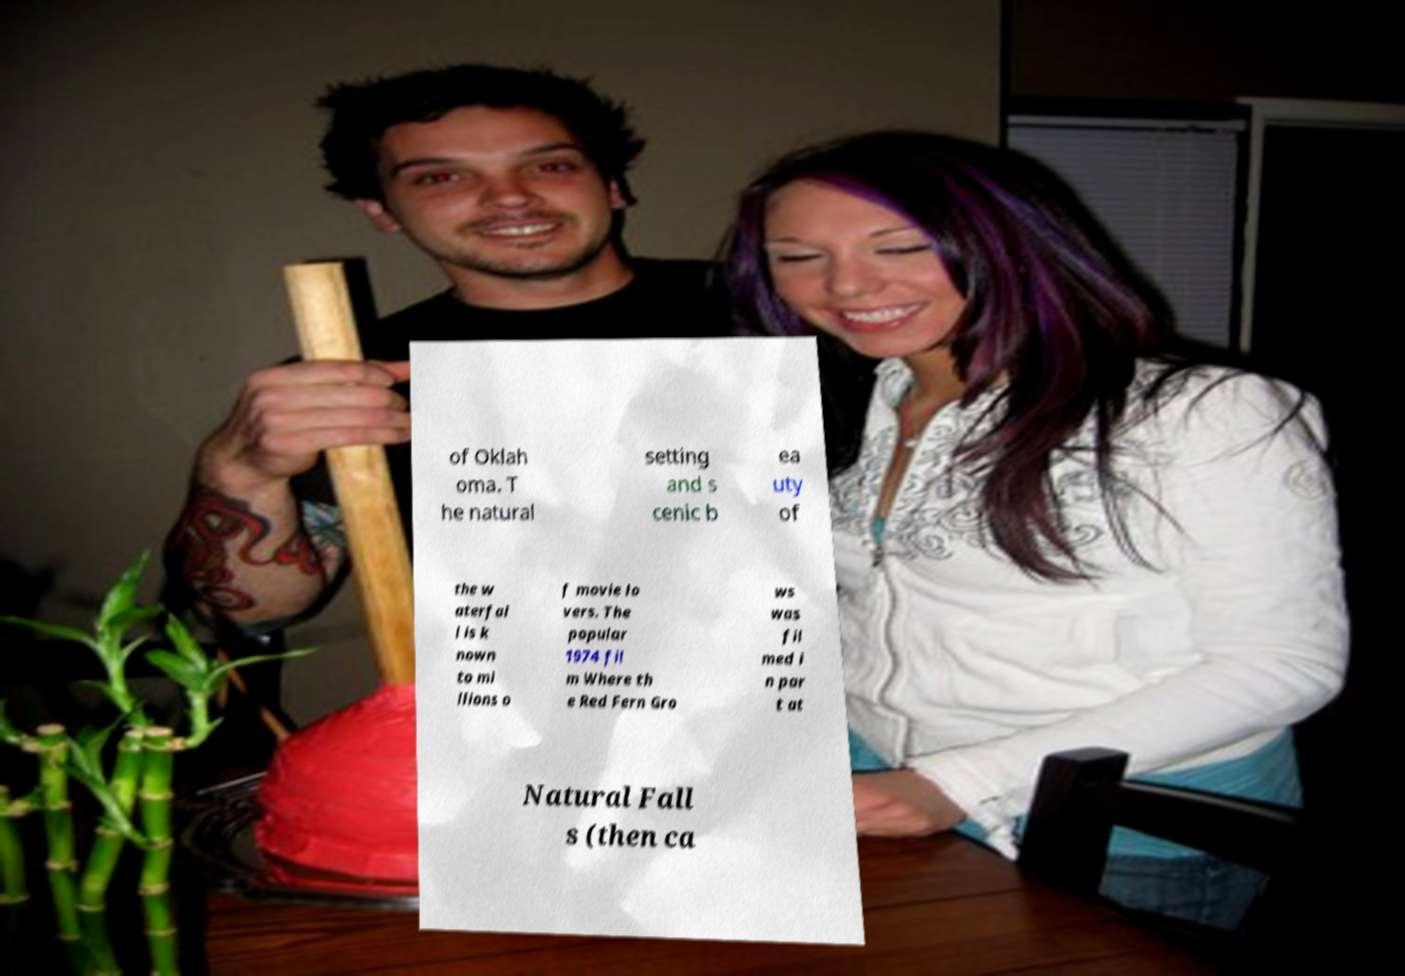Could you extract and type out the text from this image? of Oklah oma. T he natural setting and s cenic b ea uty of the w aterfal l is k nown to mi llions o f movie lo vers. The popular 1974 fil m Where th e Red Fern Gro ws was fil med i n par t at Natural Fall s (then ca 